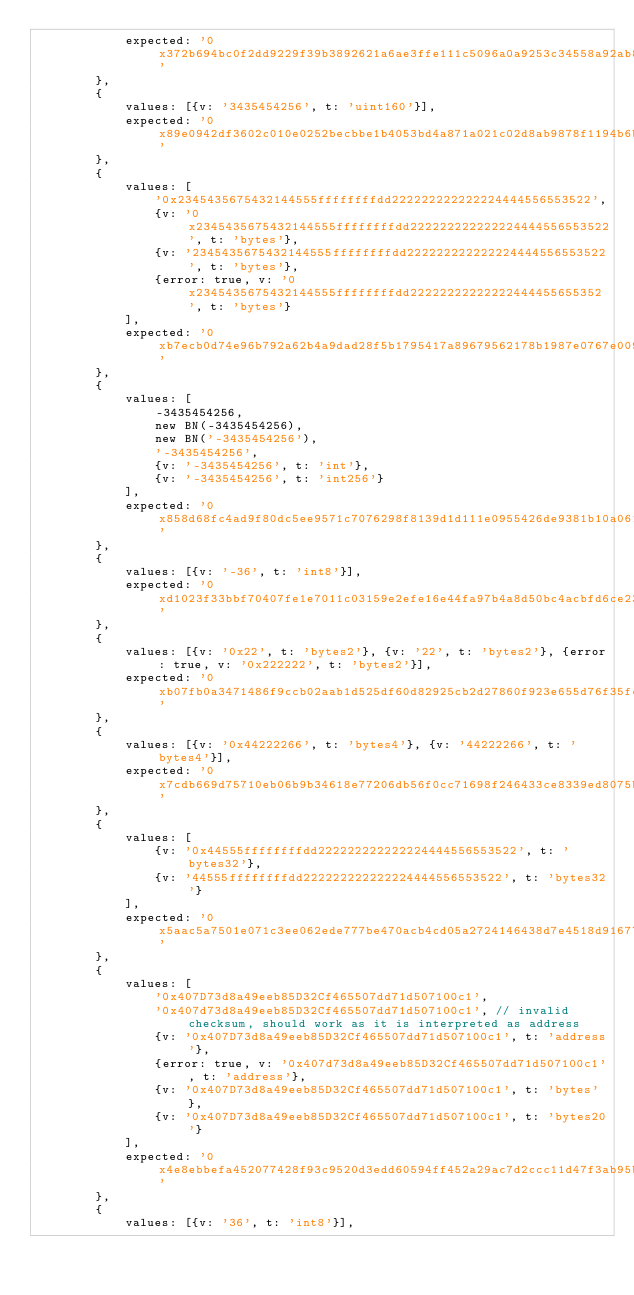<code> <loc_0><loc_0><loc_500><loc_500><_JavaScript_>            expected: '0x372b694bc0f2dd9229f39b3892621a6ae3ffe111c5096a0a9253c34558a92ab8'
        },
        {
            values: [{v: '3435454256', t: 'uint160'}],
            expected: '0x89e0942df3602c010e0252becbbe1b4053bd4a871a021c02d8ab9878f1194b6b'
        },
        {
            values: [
                '0x2345435675432144555ffffffffdd222222222222224444556553522',
                {v: '0x2345435675432144555ffffffffdd222222222222224444556553522', t: 'bytes'},
                {v: '2345435675432144555ffffffffdd222222222222224444556553522', t: 'bytes'},
                {error: true, v: '0x2345435675432144555ffffffffdd22222222222222444455655352', t: 'bytes'}
            ],
            expected: '0xb7ecb0d74e96b792a62b4a9dad28f5b1795417a89679562178b1987e0767e009'
        },
        {
            values: [
                -3435454256,
                new BN(-3435454256),
                new BN('-3435454256'),
                '-3435454256',
                {v: '-3435454256', t: 'int'},
                {v: '-3435454256', t: 'int256'}
            ],
            expected: '0x858d68fc4ad9f80dc5ee9571c7076298f8139d1d111e0955426de9381b10a061'
        },
        {
            values: [{v: '-36', t: 'int8'}],
            expected: '0xd1023f33bbf70407fe1e7011c03159e2efe16e44fa97b4a8d50bc4acbfd6ce23'
        },
        {
            values: [{v: '0x22', t: 'bytes2'}, {v: '22', t: 'bytes2'}, {error: true, v: '0x222222', t: 'bytes2'}],
            expected: '0xb07fb0a3471486f9ccb02aab1d525df60d82925cb2d27860f923e655d76f35fc'
        },
        {
            values: [{v: '0x44222266', t: 'bytes4'}, {v: '44222266', t: 'bytes4'}],
            expected: '0x7cdb669d75710eb06b9b34618e77206db56f0cc71698f246433ce8339ed8075b'
        },
        {
            values: [
                {v: '0x44555ffffffffdd222222222222224444556553522', t: 'bytes32'},
                {v: '44555ffffffffdd222222222222224444556553522', t: 'bytes32'}
            ],
            expected: '0x5aac5a7501e071c3ee062ede777be470acb4cd05a2724146438d7e4518d91677'
        },
        {
            values: [
                '0x407D73d8a49eeb85D32Cf465507dd71d507100c1',
                '0x407d73d8a49eeb85D32Cf465507dd71d507100c1', // invalid checksum, should work as it is interpreted as address
                {v: '0x407D73d8a49eeb85D32Cf465507dd71d507100c1', t: 'address'},
                {error: true, v: '0x407d73d8a49eeb85D32Cf465507dd71d507100c1', t: 'address'},
                {v: '0x407D73d8a49eeb85D32Cf465507dd71d507100c1', t: 'bytes'},
                {v: '0x407D73d8a49eeb85D32Cf465507dd71d507100c1', t: 'bytes20'}
            ],
            expected: '0x4e8ebbefa452077428f93c9520d3edd60594ff452a29ac7d2ccc11d47f3ab95b'
        },
        {
            values: [{v: '36', t: 'int8'}],</code> 